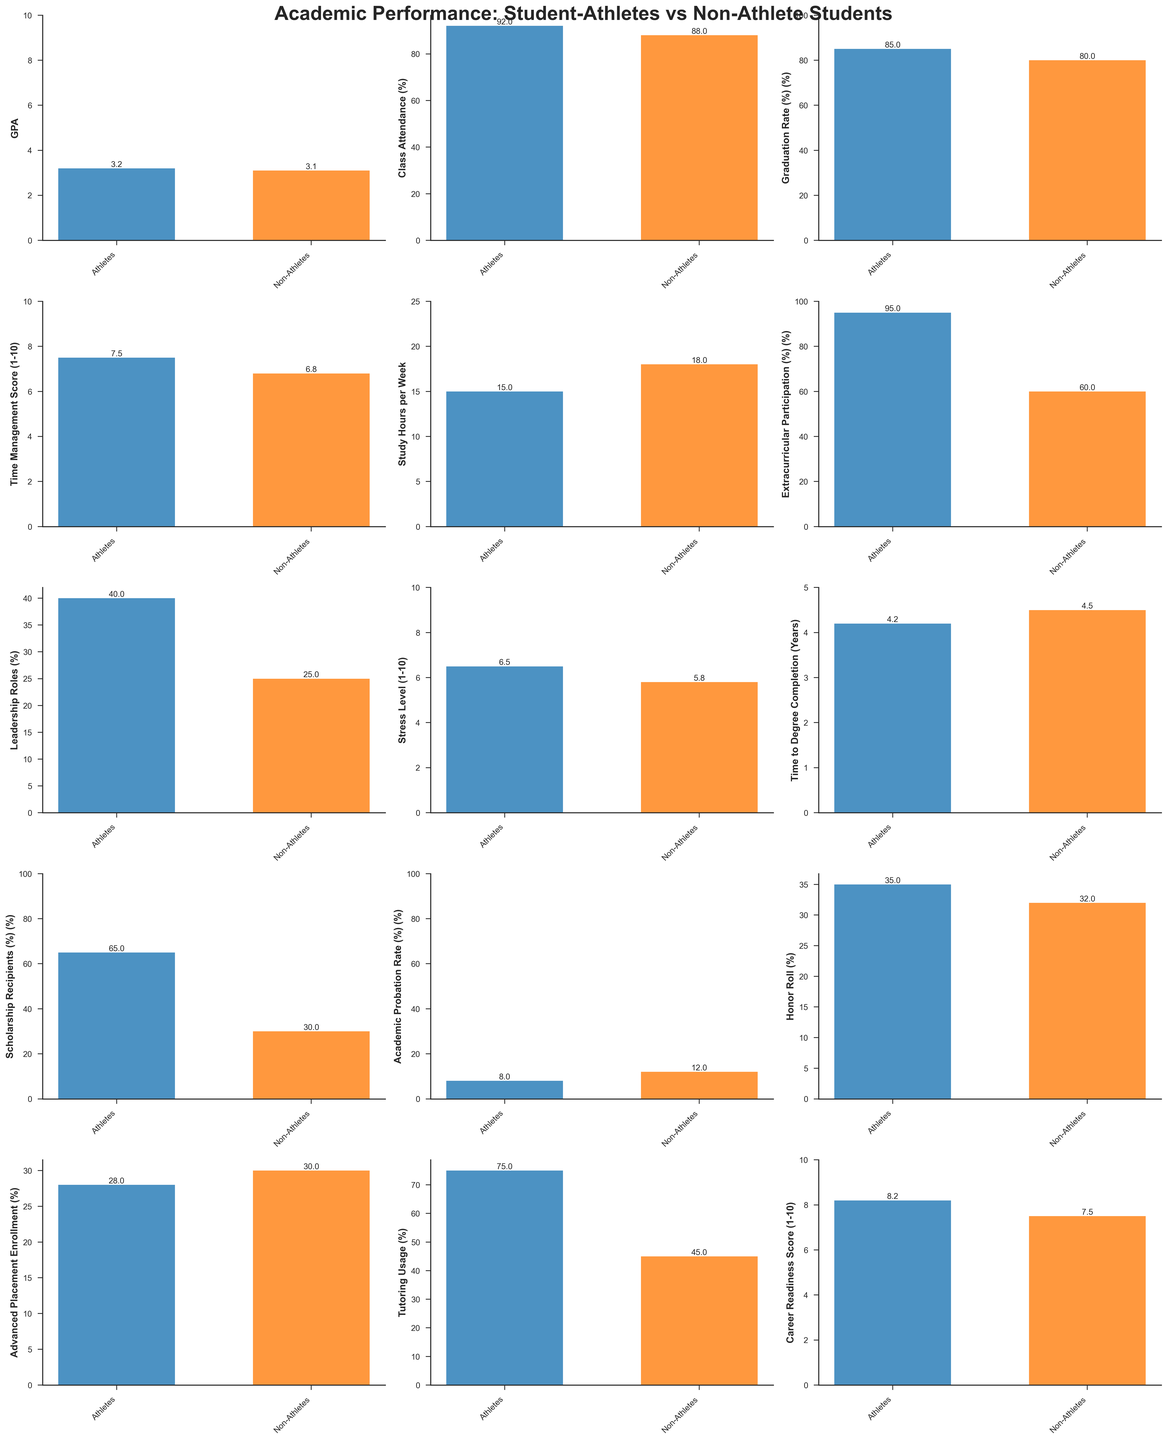Which group has a higher GPA? In the subplot for GPA, compare the heights of the bars for Student-Athletes and Non-Athlete Students. The bar for Student-Athletes is higher than the one for Non-Athlete Students.
Answer: Student-Athletes How much higher is the Class Attendance percentage for Student-Athletes compared to Non-Athlete Students? Look at the subplot for Class Attendance (%). Subtract the value for Non-Athlete Students (88%) from the value for Student-Athletes (92%). 92 - 88 = 4
Answer: 4% What is the difference in Study Hours per Week between Student-Athletes and Non-Athlete Students? In the subplot for Study Hours per Week, compare the values. Student-Athletes have 15 hours, and Non-Athlete Students have 18 hours. Subtract 15 from 18. 18 - 15 = 3
Answer: 3 hours Which group has a lower Time to Degree Completion? In the subplot for Time to Degree Completion (Years), compare the heights of the bars. The bar for Student-Athletes is shorter than the bar for Non-Athlete Students.
Answer: Student-Athletes What percentage of Student-Athletes participate in Extracurricular Activities? Look at the subplot for Extracurricular Participation (%). The bar for Student-Athletes corresponds to 95%.
Answer: 95% Are Student-Athletes or Non-Athlete Students more likely to be on Academic Probation? In the subplot for Academic Probation Rate (%), compare the heights of the bars. The bar for Non-Athlete Students is higher than the bar for Student-Athletes.
Answer: Non-Athlete Students What is the difference in Leadership Roles between Student-Athletes and Non-Athlete Students? In the subplot for Leadership Roles (%), compare the percentages. Student-Athletes have 40%, Non-Athlete Students have 25%. Subtract 25 from 40. 40 - 25 = 15
Answer: 15% How does the Tutoring Usage percentage compare between the two groups? In the subplot for Tutoring Usage (%), compare the values. Student-Athletes have 75%, and Non-Athlete Students have 45%.
Answer: Student-Athletes have a higher percentage Which group reports a higher Stress Level? In the subplot for Stress Level (1-10), compare the heights of the bars. The bar for Student-Athletes is higher than the bar for Non-Athlete Students.
Answer: Student-Athletes How many more Student-Athletes receive scholarships compared to Non-Athlete Students? In the subplot for Scholarship Recipients (%), compare the values. Subtract Non-Athlete Students' percentage (30%) from Student-Athletes' percentage (65%). 65 - 30 = 35
Answer: 35% 